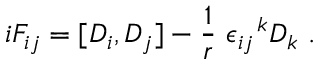Convert formula to latex. <formula><loc_0><loc_0><loc_500><loc_500>i F _ { i j } = [ D _ { i } , D _ { j } ] - \frac { 1 } { r } \epsilon _ { i j } ^ { k } D _ { k } .</formula> 